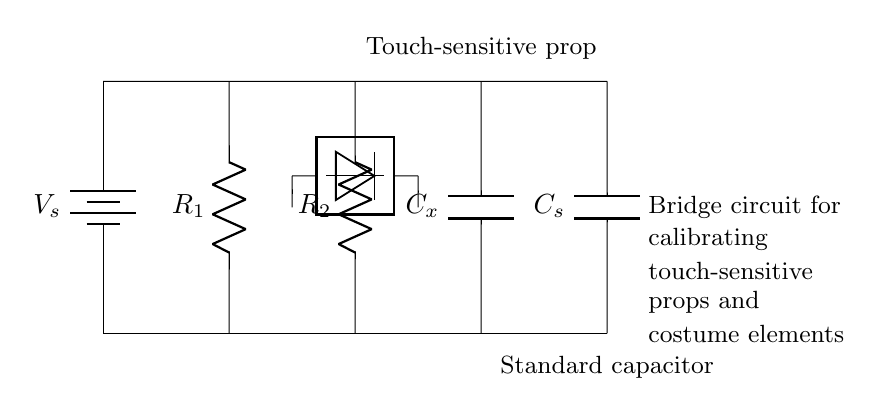What is the source voltage in the circuit? The source voltage is indicated by the label V_s next to the battery in the circuit diagram, which represents the power supply.
Answer: V_s What are the resistors represented in the circuit? The circuit shows two resistors, R_1 and R_2, connected in parallel with the capacitors. They can often be identified by the labels next to them.
Answer: R_1, R_2 What is the purpose of C_x in the circuit? C_x represents an unknown capacitance that is being tested or calibrated against the standard capacitor C_s, which is often the main purpose in a capacitance bridge circuit.
Answer: Unknown capacitance How many capacitors are present in this circuit? The circuit diagram displays two capacitors, C_x and C_s, each playing a role in the calibration process of the touch-sensitive prop.
Answer: Two What is the role of the detector in the circuit? The detector is used to sense the balance point of the bridge circuit, which indicates when the unknown capacitance C_x equals the standard capacitance C_s. This is critical for calibrating the touch-sensitive elements accurately.
Answer: Senses balance What configuration do the resistors and capacitors form in the circuit? The combination of these components forms a bridge configuration, which is used for precise measurements in comparing capacitances and calibrating devices. The layout is typical for creating a balanced bridge circuit.
Answer: Bridge configuration 